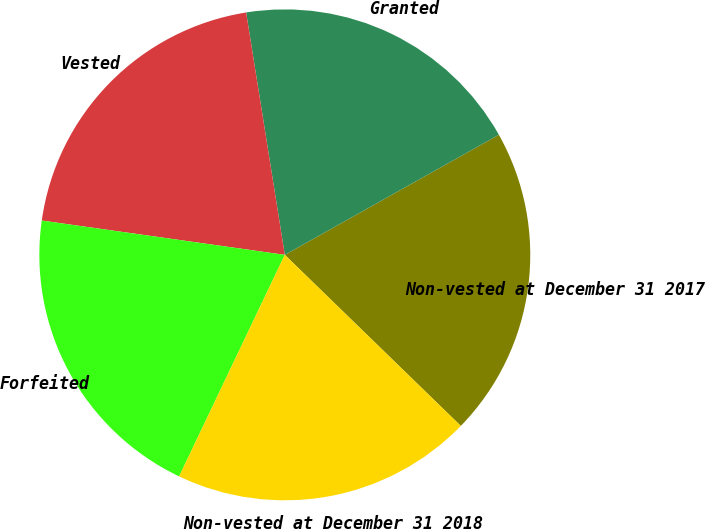Convert chart. <chart><loc_0><loc_0><loc_500><loc_500><pie_chart><fcel>Non-vested at December 31 2017<fcel>Granted<fcel>Vested<fcel>Forfeited<fcel>Non-vested at December 31 2018<nl><fcel>20.41%<fcel>19.38%<fcel>20.25%<fcel>20.15%<fcel>19.81%<nl></chart> 